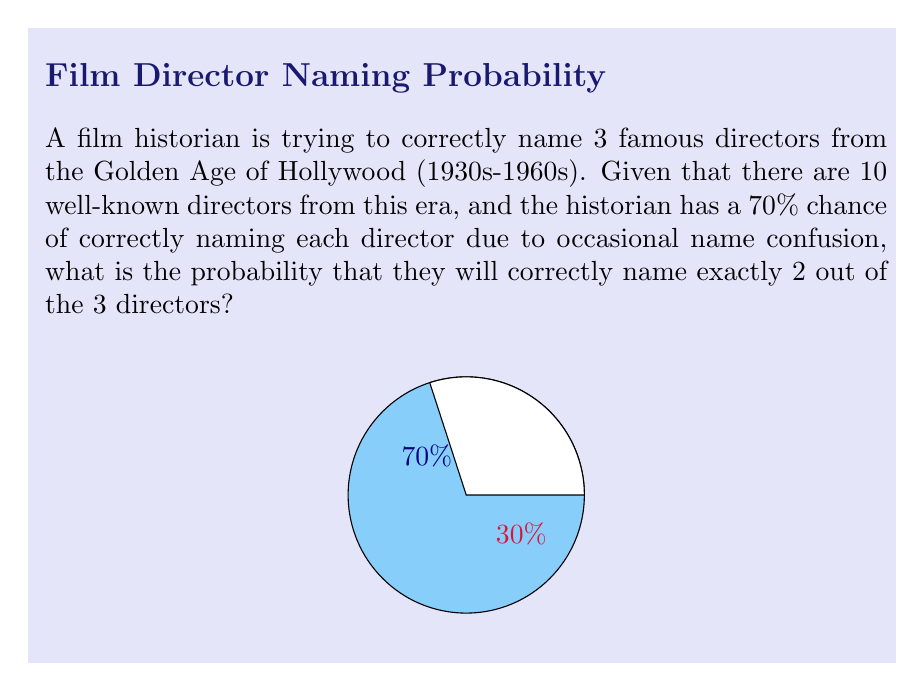Can you solve this math problem? Let's approach this step-by-step:

1) This is a binomial probability problem. We need to calculate the probability of exactly 2 successes in 3 trials.

2) The probability of success (correctly naming a director) is $p = 0.70$, and the probability of failure is $q = 1 - p = 0.30$.

3) We can use the binomial probability formula:

   $$P(X = k) = \binom{n}{k} p^k q^{n-k}$$

   where $n$ is the number of trials, $k$ is the number of successes, $p$ is the probability of success, and $q$ is the probability of failure.

4) In this case, $n = 3$, $k = 2$, $p = 0.70$, and $q = 0.30$.

5) First, let's calculate the binomial coefficient:

   $$\binom{3}{2} = \frac{3!}{2!(3-2)!} = \frac{3 \cdot 2 \cdot 1}{(2 \cdot 1)(1)} = 3$$

6) Now, let's plug everything into the formula:

   $$P(X = 2) = 3 \cdot (0.70)^2 \cdot (0.30)^{3-2}$$

7) Simplify:

   $$P(X = 2) = 3 \cdot (0.70)^2 \cdot (0.30)^1 = 3 \cdot 0.49 \cdot 0.30 = 0.441$$

8) Therefore, the probability of correctly naming exactly 2 out of 3 directors is 0.441 or 44.1%.
Answer: 0.441 